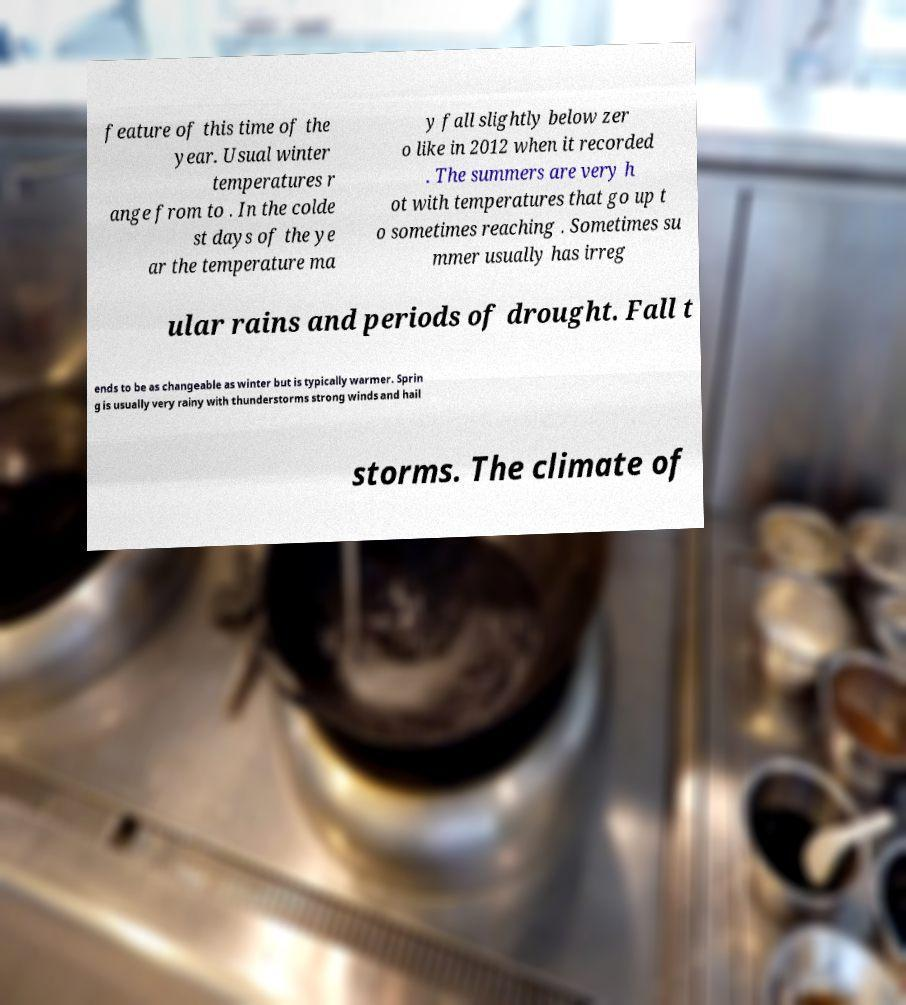Could you extract and type out the text from this image? feature of this time of the year. Usual winter temperatures r ange from to . In the colde st days of the ye ar the temperature ma y fall slightly below zer o like in 2012 when it recorded . The summers are very h ot with temperatures that go up t o sometimes reaching . Sometimes su mmer usually has irreg ular rains and periods of drought. Fall t ends to be as changeable as winter but is typically warmer. Sprin g is usually very rainy with thunderstorms strong winds and hail storms. The climate of 